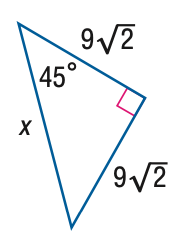Answer the mathemtical geometry problem and directly provide the correct option letter.
Question: Find x.
Choices: A: 9 B: 6 \sqrt { 6 } C: 18 D: 18 \sqrt { 2 } C 